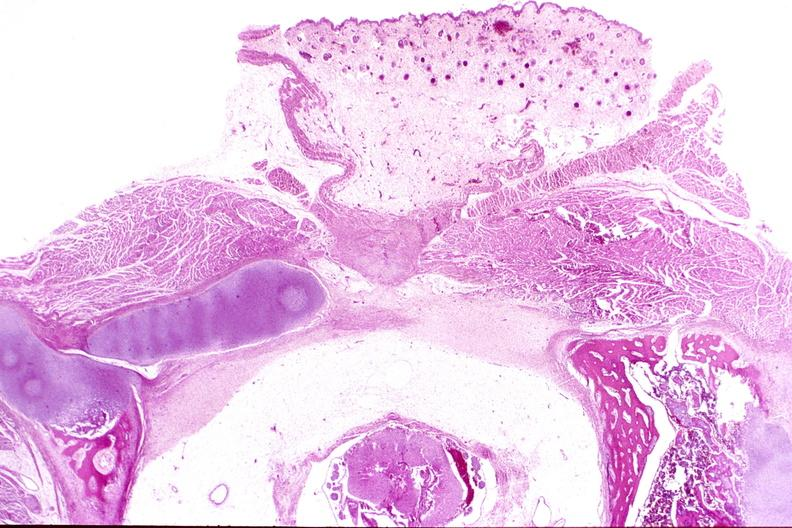s nervous present?
Answer the question using a single word or phrase. Yes 